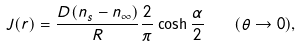<formula> <loc_0><loc_0><loc_500><loc_500>J ( r ) = \frac { D ( n _ { s } - n _ { \infty } ) } R \frac { 2 } \pi \cosh \frac { \alpha } 2 \quad ( \theta \to 0 ) ,</formula> 